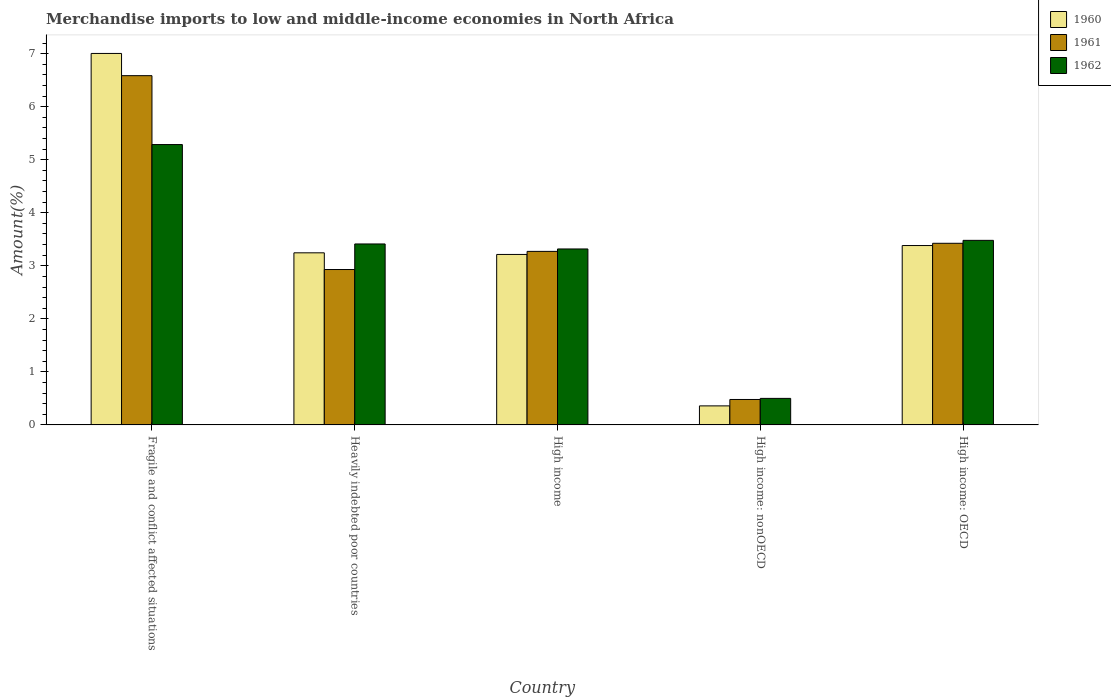How many different coloured bars are there?
Give a very brief answer. 3. Are the number of bars on each tick of the X-axis equal?
Make the answer very short. Yes. How many bars are there on the 3rd tick from the left?
Give a very brief answer. 3. What is the label of the 3rd group of bars from the left?
Offer a terse response. High income. What is the percentage of amount earned from merchandise imports in 1961 in Fragile and conflict affected situations?
Your answer should be very brief. 6.58. Across all countries, what is the maximum percentage of amount earned from merchandise imports in 1960?
Keep it short and to the point. 7. Across all countries, what is the minimum percentage of amount earned from merchandise imports in 1962?
Offer a terse response. 0.5. In which country was the percentage of amount earned from merchandise imports in 1962 maximum?
Your answer should be very brief. Fragile and conflict affected situations. In which country was the percentage of amount earned from merchandise imports in 1960 minimum?
Give a very brief answer. High income: nonOECD. What is the total percentage of amount earned from merchandise imports in 1962 in the graph?
Make the answer very short. 15.99. What is the difference between the percentage of amount earned from merchandise imports in 1962 in Heavily indebted poor countries and that in High income: OECD?
Provide a succinct answer. -0.07. What is the difference between the percentage of amount earned from merchandise imports in 1961 in High income: nonOECD and the percentage of amount earned from merchandise imports in 1962 in Heavily indebted poor countries?
Provide a short and direct response. -2.93. What is the average percentage of amount earned from merchandise imports in 1962 per country?
Give a very brief answer. 3.2. What is the difference between the percentage of amount earned from merchandise imports of/in 1961 and percentage of amount earned from merchandise imports of/in 1962 in Fragile and conflict affected situations?
Provide a short and direct response. 1.3. What is the ratio of the percentage of amount earned from merchandise imports in 1961 in Fragile and conflict affected situations to that in High income: OECD?
Offer a very short reply. 1.92. What is the difference between the highest and the second highest percentage of amount earned from merchandise imports in 1960?
Offer a terse response. -0.14. What is the difference between the highest and the lowest percentage of amount earned from merchandise imports in 1961?
Provide a succinct answer. 6.11. In how many countries, is the percentage of amount earned from merchandise imports in 1961 greater than the average percentage of amount earned from merchandise imports in 1961 taken over all countries?
Offer a very short reply. 2. What does the 2nd bar from the left in High income: OECD represents?
Offer a very short reply. 1961. How many bars are there?
Ensure brevity in your answer.  15. Are all the bars in the graph horizontal?
Your response must be concise. No. What is the difference between two consecutive major ticks on the Y-axis?
Ensure brevity in your answer.  1. Are the values on the major ticks of Y-axis written in scientific E-notation?
Your answer should be compact. No. Does the graph contain any zero values?
Provide a short and direct response. No. Does the graph contain grids?
Offer a very short reply. No. How many legend labels are there?
Offer a terse response. 3. What is the title of the graph?
Your answer should be compact. Merchandise imports to low and middle-income economies in North Africa. What is the label or title of the X-axis?
Your response must be concise. Country. What is the label or title of the Y-axis?
Ensure brevity in your answer.  Amount(%). What is the Amount(%) in 1960 in Fragile and conflict affected situations?
Provide a succinct answer. 7. What is the Amount(%) of 1961 in Fragile and conflict affected situations?
Give a very brief answer. 6.58. What is the Amount(%) of 1962 in Fragile and conflict affected situations?
Offer a very short reply. 5.29. What is the Amount(%) of 1960 in Heavily indebted poor countries?
Ensure brevity in your answer.  3.24. What is the Amount(%) in 1961 in Heavily indebted poor countries?
Your answer should be very brief. 2.93. What is the Amount(%) in 1962 in Heavily indebted poor countries?
Provide a succinct answer. 3.41. What is the Amount(%) of 1960 in High income?
Your response must be concise. 3.21. What is the Amount(%) of 1961 in High income?
Offer a very short reply. 3.27. What is the Amount(%) in 1962 in High income?
Your response must be concise. 3.32. What is the Amount(%) of 1960 in High income: nonOECD?
Ensure brevity in your answer.  0.36. What is the Amount(%) in 1961 in High income: nonOECD?
Offer a terse response. 0.48. What is the Amount(%) in 1962 in High income: nonOECD?
Keep it short and to the point. 0.5. What is the Amount(%) in 1960 in High income: OECD?
Ensure brevity in your answer.  3.38. What is the Amount(%) of 1961 in High income: OECD?
Make the answer very short. 3.42. What is the Amount(%) of 1962 in High income: OECD?
Your answer should be compact. 3.48. Across all countries, what is the maximum Amount(%) of 1960?
Ensure brevity in your answer.  7. Across all countries, what is the maximum Amount(%) of 1961?
Make the answer very short. 6.58. Across all countries, what is the maximum Amount(%) of 1962?
Make the answer very short. 5.29. Across all countries, what is the minimum Amount(%) of 1960?
Your response must be concise. 0.36. Across all countries, what is the minimum Amount(%) in 1961?
Give a very brief answer. 0.48. Across all countries, what is the minimum Amount(%) in 1962?
Keep it short and to the point. 0.5. What is the total Amount(%) of 1960 in the graph?
Your response must be concise. 17.2. What is the total Amount(%) of 1961 in the graph?
Keep it short and to the point. 16.69. What is the total Amount(%) in 1962 in the graph?
Offer a terse response. 15.99. What is the difference between the Amount(%) of 1960 in Fragile and conflict affected situations and that in Heavily indebted poor countries?
Keep it short and to the point. 3.76. What is the difference between the Amount(%) of 1961 in Fragile and conflict affected situations and that in Heavily indebted poor countries?
Your answer should be compact. 3.66. What is the difference between the Amount(%) of 1962 in Fragile and conflict affected situations and that in Heavily indebted poor countries?
Keep it short and to the point. 1.87. What is the difference between the Amount(%) of 1960 in Fragile and conflict affected situations and that in High income?
Your answer should be very brief. 3.79. What is the difference between the Amount(%) of 1961 in Fragile and conflict affected situations and that in High income?
Your response must be concise. 3.31. What is the difference between the Amount(%) of 1962 in Fragile and conflict affected situations and that in High income?
Give a very brief answer. 1.97. What is the difference between the Amount(%) of 1960 in Fragile and conflict affected situations and that in High income: nonOECD?
Keep it short and to the point. 6.64. What is the difference between the Amount(%) of 1961 in Fragile and conflict affected situations and that in High income: nonOECD?
Ensure brevity in your answer.  6.11. What is the difference between the Amount(%) of 1962 in Fragile and conflict affected situations and that in High income: nonOECD?
Provide a short and direct response. 4.79. What is the difference between the Amount(%) of 1960 in Fragile and conflict affected situations and that in High income: OECD?
Keep it short and to the point. 3.62. What is the difference between the Amount(%) of 1961 in Fragile and conflict affected situations and that in High income: OECD?
Offer a terse response. 3.16. What is the difference between the Amount(%) of 1962 in Fragile and conflict affected situations and that in High income: OECD?
Provide a short and direct response. 1.81. What is the difference between the Amount(%) in 1960 in Heavily indebted poor countries and that in High income?
Offer a terse response. 0.03. What is the difference between the Amount(%) of 1961 in Heavily indebted poor countries and that in High income?
Offer a very short reply. -0.34. What is the difference between the Amount(%) of 1962 in Heavily indebted poor countries and that in High income?
Provide a short and direct response. 0.09. What is the difference between the Amount(%) of 1960 in Heavily indebted poor countries and that in High income: nonOECD?
Your answer should be very brief. 2.89. What is the difference between the Amount(%) in 1961 in Heavily indebted poor countries and that in High income: nonOECD?
Provide a succinct answer. 2.45. What is the difference between the Amount(%) in 1962 in Heavily indebted poor countries and that in High income: nonOECD?
Give a very brief answer. 2.91. What is the difference between the Amount(%) in 1960 in Heavily indebted poor countries and that in High income: OECD?
Keep it short and to the point. -0.14. What is the difference between the Amount(%) of 1961 in Heavily indebted poor countries and that in High income: OECD?
Your answer should be compact. -0.49. What is the difference between the Amount(%) of 1962 in Heavily indebted poor countries and that in High income: OECD?
Make the answer very short. -0.07. What is the difference between the Amount(%) in 1960 in High income and that in High income: nonOECD?
Provide a succinct answer. 2.86. What is the difference between the Amount(%) of 1961 in High income and that in High income: nonOECD?
Your response must be concise. 2.79. What is the difference between the Amount(%) of 1962 in High income and that in High income: nonOECD?
Give a very brief answer. 2.82. What is the difference between the Amount(%) of 1960 in High income and that in High income: OECD?
Your answer should be compact. -0.17. What is the difference between the Amount(%) in 1961 in High income and that in High income: OECD?
Provide a short and direct response. -0.15. What is the difference between the Amount(%) in 1962 in High income and that in High income: OECD?
Your answer should be very brief. -0.16. What is the difference between the Amount(%) of 1960 in High income: nonOECD and that in High income: OECD?
Offer a terse response. -3.02. What is the difference between the Amount(%) in 1961 in High income: nonOECD and that in High income: OECD?
Make the answer very short. -2.94. What is the difference between the Amount(%) of 1962 in High income: nonOECD and that in High income: OECD?
Provide a short and direct response. -2.98. What is the difference between the Amount(%) in 1960 in Fragile and conflict affected situations and the Amount(%) in 1961 in Heavily indebted poor countries?
Your response must be concise. 4.07. What is the difference between the Amount(%) in 1960 in Fragile and conflict affected situations and the Amount(%) in 1962 in Heavily indebted poor countries?
Keep it short and to the point. 3.59. What is the difference between the Amount(%) of 1961 in Fragile and conflict affected situations and the Amount(%) of 1962 in Heavily indebted poor countries?
Keep it short and to the point. 3.17. What is the difference between the Amount(%) in 1960 in Fragile and conflict affected situations and the Amount(%) in 1961 in High income?
Keep it short and to the point. 3.73. What is the difference between the Amount(%) of 1960 in Fragile and conflict affected situations and the Amount(%) of 1962 in High income?
Offer a very short reply. 3.69. What is the difference between the Amount(%) in 1961 in Fragile and conflict affected situations and the Amount(%) in 1962 in High income?
Ensure brevity in your answer.  3.27. What is the difference between the Amount(%) of 1960 in Fragile and conflict affected situations and the Amount(%) of 1961 in High income: nonOECD?
Offer a very short reply. 6.52. What is the difference between the Amount(%) in 1960 in Fragile and conflict affected situations and the Amount(%) in 1962 in High income: nonOECD?
Make the answer very short. 6.5. What is the difference between the Amount(%) of 1961 in Fragile and conflict affected situations and the Amount(%) of 1962 in High income: nonOECD?
Your answer should be compact. 6.08. What is the difference between the Amount(%) of 1960 in Fragile and conflict affected situations and the Amount(%) of 1961 in High income: OECD?
Keep it short and to the point. 3.58. What is the difference between the Amount(%) in 1960 in Fragile and conflict affected situations and the Amount(%) in 1962 in High income: OECD?
Give a very brief answer. 3.52. What is the difference between the Amount(%) in 1961 in Fragile and conflict affected situations and the Amount(%) in 1962 in High income: OECD?
Your answer should be very brief. 3.11. What is the difference between the Amount(%) in 1960 in Heavily indebted poor countries and the Amount(%) in 1961 in High income?
Provide a succinct answer. -0.03. What is the difference between the Amount(%) in 1960 in Heavily indebted poor countries and the Amount(%) in 1962 in High income?
Ensure brevity in your answer.  -0.07. What is the difference between the Amount(%) of 1961 in Heavily indebted poor countries and the Amount(%) of 1962 in High income?
Make the answer very short. -0.39. What is the difference between the Amount(%) of 1960 in Heavily indebted poor countries and the Amount(%) of 1961 in High income: nonOECD?
Provide a succinct answer. 2.77. What is the difference between the Amount(%) of 1960 in Heavily indebted poor countries and the Amount(%) of 1962 in High income: nonOECD?
Ensure brevity in your answer.  2.74. What is the difference between the Amount(%) in 1961 in Heavily indebted poor countries and the Amount(%) in 1962 in High income: nonOECD?
Provide a succinct answer. 2.43. What is the difference between the Amount(%) of 1960 in Heavily indebted poor countries and the Amount(%) of 1961 in High income: OECD?
Give a very brief answer. -0.18. What is the difference between the Amount(%) in 1960 in Heavily indebted poor countries and the Amount(%) in 1962 in High income: OECD?
Provide a short and direct response. -0.23. What is the difference between the Amount(%) in 1961 in Heavily indebted poor countries and the Amount(%) in 1962 in High income: OECD?
Give a very brief answer. -0.55. What is the difference between the Amount(%) in 1960 in High income and the Amount(%) in 1961 in High income: nonOECD?
Provide a succinct answer. 2.73. What is the difference between the Amount(%) in 1960 in High income and the Amount(%) in 1962 in High income: nonOECD?
Your response must be concise. 2.71. What is the difference between the Amount(%) in 1961 in High income and the Amount(%) in 1962 in High income: nonOECD?
Your answer should be very brief. 2.77. What is the difference between the Amount(%) in 1960 in High income and the Amount(%) in 1961 in High income: OECD?
Your response must be concise. -0.21. What is the difference between the Amount(%) in 1960 in High income and the Amount(%) in 1962 in High income: OECD?
Provide a succinct answer. -0.27. What is the difference between the Amount(%) of 1961 in High income and the Amount(%) of 1962 in High income: OECD?
Offer a terse response. -0.21. What is the difference between the Amount(%) in 1960 in High income: nonOECD and the Amount(%) in 1961 in High income: OECD?
Make the answer very short. -3.07. What is the difference between the Amount(%) of 1960 in High income: nonOECD and the Amount(%) of 1962 in High income: OECD?
Your answer should be compact. -3.12. What is the difference between the Amount(%) of 1961 in High income: nonOECD and the Amount(%) of 1962 in High income: OECD?
Ensure brevity in your answer.  -3. What is the average Amount(%) of 1960 per country?
Make the answer very short. 3.44. What is the average Amount(%) in 1961 per country?
Give a very brief answer. 3.34. What is the average Amount(%) in 1962 per country?
Provide a succinct answer. 3.2. What is the difference between the Amount(%) of 1960 and Amount(%) of 1961 in Fragile and conflict affected situations?
Your answer should be very brief. 0.42. What is the difference between the Amount(%) in 1960 and Amount(%) in 1962 in Fragile and conflict affected situations?
Your response must be concise. 1.72. What is the difference between the Amount(%) of 1961 and Amount(%) of 1962 in Fragile and conflict affected situations?
Keep it short and to the point. 1.3. What is the difference between the Amount(%) of 1960 and Amount(%) of 1961 in Heavily indebted poor countries?
Give a very brief answer. 0.32. What is the difference between the Amount(%) of 1960 and Amount(%) of 1962 in Heavily indebted poor countries?
Your response must be concise. -0.17. What is the difference between the Amount(%) in 1961 and Amount(%) in 1962 in Heavily indebted poor countries?
Provide a short and direct response. -0.48. What is the difference between the Amount(%) in 1960 and Amount(%) in 1961 in High income?
Provide a short and direct response. -0.06. What is the difference between the Amount(%) of 1960 and Amount(%) of 1962 in High income?
Ensure brevity in your answer.  -0.1. What is the difference between the Amount(%) in 1961 and Amount(%) in 1962 in High income?
Provide a short and direct response. -0.05. What is the difference between the Amount(%) of 1960 and Amount(%) of 1961 in High income: nonOECD?
Ensure brevity in your answer.  -0.12. What is the difference between the Amount(%) of 1960 and Amount(%) of 1962 in High income: nonOECD?
Offer a very short reply. -0.14. What is the difference between the Amount(%) in 1961 and Amount(%) in 1962 in High income: nonOECD?
Your response must be concise. -0.02. What is the difference between the Amount(%) of 1960 and Amount(%) of 1961 in High income: OECD?
Your answer should be very brief. -0.04. What is the difference between the Amount(%) in 1960 and Amount(%) in 1962 in High income: OECD?
Keep it short and to the point. -0.1. What is the difference between the Amount(%) in 1961 and Amount(%) in 1962 in High income: OECD?
Offer a terse response. -0.06. What is the ratio of the Amount(%) in 1960 in Fragile and conflict affected situations to that in Heavily indebted poor countries?
Provide a succinct answer. 2.16. What is the ratio of the Amount(%) in 1961 in Fragile and conflict affected situations to that in Heavily indebted poor countries?
Your answer should be compact. 2.25. What is the ratio of the Amount(%) in 1962 in Fragile and conflict affected situations to that in Heavily indebted poor countries?
Ensure brevity in your answer.  1.55. What is the ratio of the Amount(%) of 1960 in Fragile and conflict affected situations to that in High income?
Ensure brevity in your answer.  2.18. What is the ratio of the Amount(%) in 1961 in Fragile and conflict affected situations to that in High income?
Offer a terse response. 2.01. What is the ratio of the Amount(%) of 1962 in Fragile and conflict affected situations to that in High income?
Provide a succinct answer. 1.59. What is the ratio of the Amount(%) in 1960 in Fragile and conflict affected situations to that in High income: nonOECD?
Ensure brevity in your answer.  19.53. What is the ratio of the Amount(%) of 1961 in Fragile and conflict affected situations to that in High income: nonOECD?
Provide a succinct answer. 13.73. What is the ratio of the Amount(%) of 1962 in Fragile and conflict affected situations to that in High income: nonOECD?
Keep it short and to the point. 10.57. What is the ratio of the Amount(%) of 1960 in Fragile and conflict affected situations to that in High income: OECD?
Your response must be concise. 2.07. What is the ratio of the Amount(%) in 1961 in Fragile and conflict affected situations to that in High income: OECD?
Your answer should be very brief. 1.92. What is the ratio of the Amount(%) in 1962 in Fragile and conflict affected situations to that in High income: OECD?
Your answer should be very brief. 1.52. What is the ratio of the Amount(%) in 1960 in Heavily indebted poor countries to that in High income?
Offer a very short reply. 1.01. What is the ratio of the Amount(%) in 1961 in Heavily indebted poor countries to that in High income?
Ensure brevity in your answer.  0.9. What is the ratio of the Amount(%) in 1962 in Heavily indebted poor countries to that in High income?
Make the answer very short. 1.03. What is the ratio of the Amount(%) of 1960 in Heavily indebted poor countries to that in High income: nonOECD?
Your response must be concise. 9.05. What is the ratio of the Amount(%) in 1961 in Heavily indebted poor countries to that in High income: nonOECD?
Provide a succinct answer. 6.11. What is the ratio of the Amount(%) of 1962 in Heavily indebted poor countries to that in High income: nonOECD?
Ensure brevity in your answer.  6.82. What is the ratio of the Amount(%) of 1960 in Heavily indebted poor countries to that in High income: OECD?
Give a very brief answer. 0.96. What is the ratio of the Amount(%) in 1961 in Heavily indebted poor countries to that in High income: OECD?
Your answer should be very brief. 0.86. What is the ratio of the Amount(%) in 1962 in Heavily indebted poor countries to that in High income: OECD?
Offer a very short reply. 0.98. What is the ratio of the Amount(%) of 1960 in High income to that in High income: nonOECD?
Make the answer very short. 8.96. What is the ratio of the Amount(%) of 1961 in High income to that in High income: nonOECD?
Give a very brief answer. 6.82. What is the ratio of the Amount(%) in 1962 in High income to that in High income: nonOECD?
Offer a very short reply. 6.63. What is the ratio of the Amount(%) of 1960 in High income to that in High income: OECD?
Offer a terse response. 0.95. What is the ratio of the Amount(%) in 1961 in High income to that in High income: OECD?
Offer a very short reply. 0.96. What is the ratio of the Amount(%) of 1962 in High income to that in High income: OECD?
Your answer should be very brief. 0.95. What is the ratio of the Amount(%) in 1960 in High income: nonOECD to that in High income: OECD?
Offer a terse response. 0.11. What is the ratio of the Amount(%) of 1961 in High income: nonOECD to that in High income: OECD?
Your response must be concise. 0.14. What is the ratio of the Amount(%) in 1962 in High income: nonOECD to that in High income: OECD?
Give a very brief answer. 0.14. What is the difference between the highest and the second highest Amount(%) in 1960?
Keep it short and to the point. 3.62. What is the difference between the highest and the second highest Amount(%) of 1961?
Give a very brief answer. 3.16. What is the difference between the highest and the second highest Amount(%) of 1962?
Keep it short and to the point. 1.81. What is the difference between the highest and the lowest Amount(%) of 1960?
Make the answer very short. 6.64. What is the difference between the highest and the lowest Amount(%) of 1961?
Ensure brevity in your answer.  6.11. What is the difference between the highest and the lowest Amount(%) of 1962?
Your answer should be very brief. 4.79. 